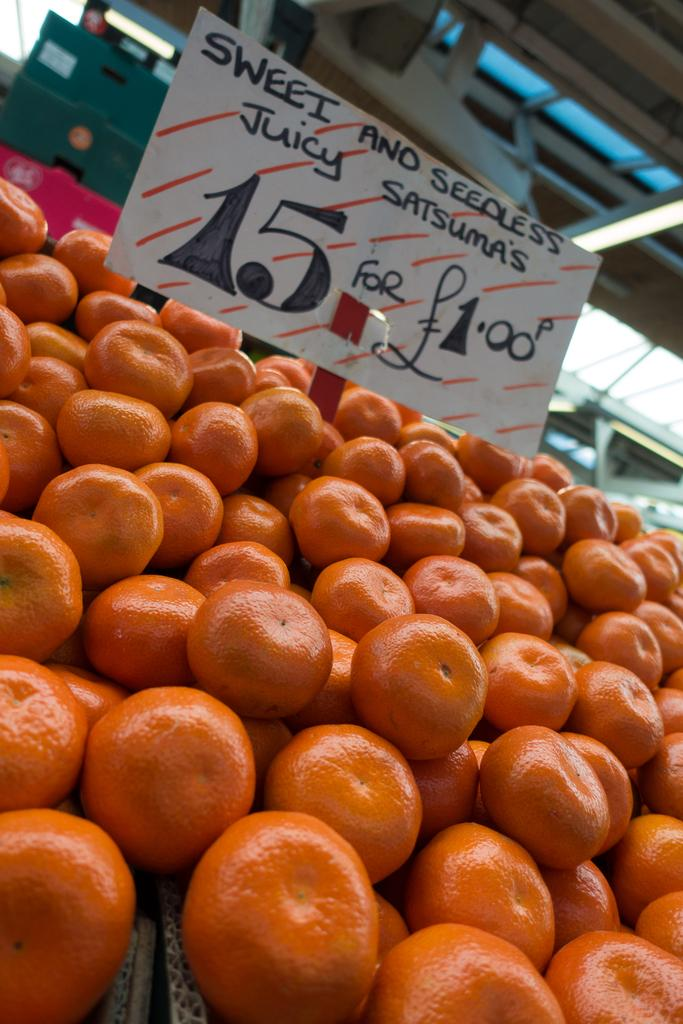What type of fruit is present in the image? There are oranges in the image. What can be seen near the oranges? There is a price board in the image. Where is the price board located in relation to the oranges? The price board is located among the oranges. What structure is visible at the top of the image? There is a shed visible at the top of the image. How many children are interacting with the oranges in the image? There are no children present in the image; it only features oranges, a price board, and a shed. 